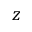Convert formula to latex. <formula><loc_0><loc_0><loc_500><loc_500>z</formula> 